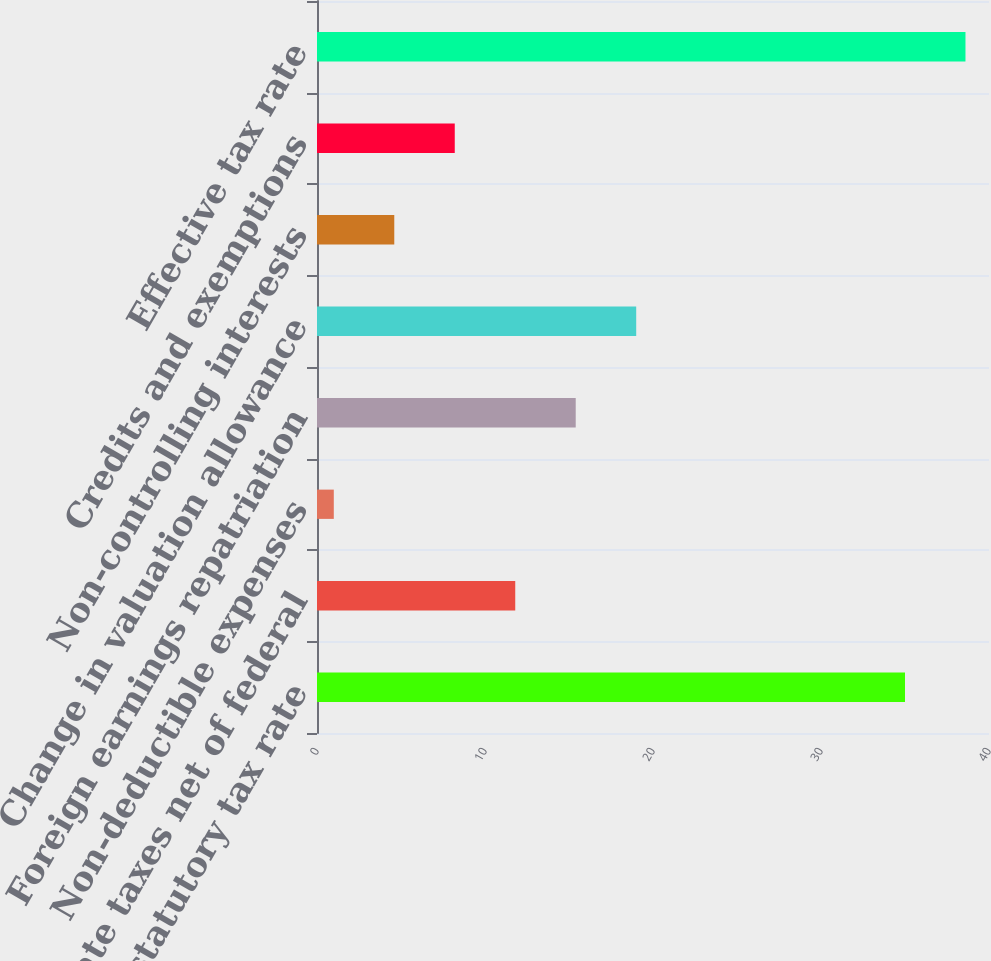Convert chart. <chart><loc_0><loc_0><loc_500><loc_500><bar_chart><fcel>Federal statutory tax rate<fcel>State taxes net of federal<fcel>Non-deductible expenses<fcel>Foreign earnings repatriation<fcel>Change in valuation allowance<fcel>Non-controlling interests<fcel>Credits and exemptions<fcel>Effective tax rate<nl><fcel>35<fcel>11.8<fcel>1<fcel>15.4<fcel>19<fcel>4.6<fcel>8.2<fcel>38.6<nl></chart> 